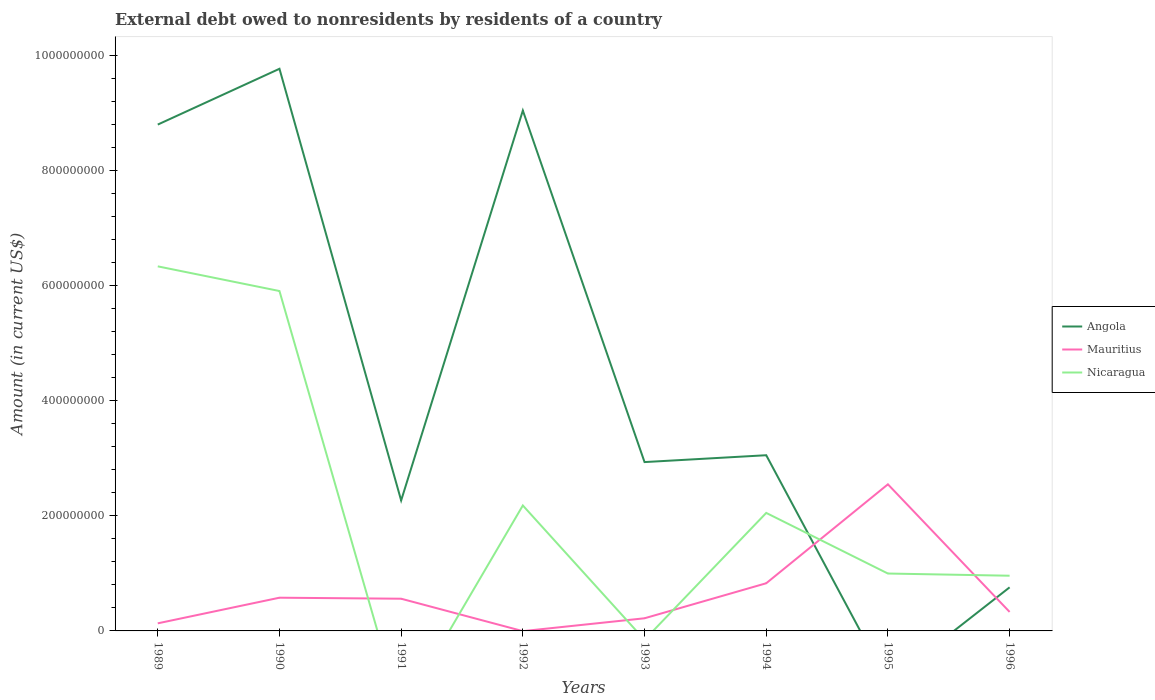Does the line corresponding to Angola intersect with the line corresponding to Nicaragua?
Provide a short and direct response. Yes. What is the total external debt owed by residents in Angola in the graph?
Your answer should be compact. -6.78e+08. What is the difference between the highest and the second highest external debt owed by residents in Angola?
Give a very brief answer. 9.77e+08. What is the difference between the highest and the lowest external debt owed by residents in Angola?
Provide a short and direct response. 3. How many lines are there?
Give a very brief answer. 3. How many years are there in the graph?
Your answer should be very brief. 8. What is the difference between two consecutive major ticks on the Y-axis?
Keep it short and to the point. 2.00e+08. Are the values on the major ticks of Y-axis written in scientific E-notation?
Your answer should be very brief. No. Does the graph contain any zero values?
Your answer should be compact. Yes. Does the graph contain grids?
Provide a succinct answer. No. Where does the legend appear in the graph?
Keep it short and to the point. Center right. What is the title of the graph?
Your answer should be very brief. External debt owed to nonresidents by residents of a country. What is the label or title of the X-axis?
Give a very brief answer. Years. What is the Amount (in current US$) in Angola in 1989?
Offer a terse response. 8.80e+08. What is the Amount (in current US$) in Mauritius in 1989?
Make the answer very short. 1.32e+07. What is the Amount (in current US$) in Nicaragua in 1989?
Provide a short and direct response. 6.34e+08. What is the Amount (in current US$) of Angola in 1990?
Offer a terse response. 9.77e+08. What is the Amount (in current US$) in Mauritius in 1990?
Offer a terse response. 5.77e+07. What is the Amount (in current US$) of Nicaragua in 1990?
Your answer should be very brief. 5.91e+08. What is the Amount (in current US$) in Angola in 1991?
Keep it short and to the point. 2.27e+08. What is the Amount (in current US$) in Mauritius in 1991?
Your answer should be very brief. 5.60e+07. What is the Amount (in current US$) in Nicaragua in 1991?
Your response must be concise. 0. What is the Amount (in current US$) of Angola in 1992?
Make the answer very short. 9.05e+08. What is the Amount (in current US$) of Mauritius in 1992?
Your answer should be very brief. 0. What is the Amount (in current US$) of Nicaragua in 1992?
Make the answer very short. 2.18e+08. What is the Amount (in current US$) of Angola in 1993?
Your response must be concise. 2.94e+08. What is the Amount (in current US$) in Mauritius in 1993?
Your answer should be compact. 2.20e+07. What is the Amount (in current US$) of Nicaragua in 1993?
Your answer should be very brief. 0. What is the Amount (in current US$) of Angola in 1994?
Provide a succinct answer. 3.05e+08. What is the Amount (in current US$) in Mauritius in 1994?
Keep it short and to the point. 8.28e+07. What is the Amount (in current US$) in Nicaragua in 1994?
Keep it short and to the point. 2.05e+08. What is the Amount (in current US$) in Angola in 1995?
Your answer should be compact. 0. What is the Amount (in current US$) in Mauritius in 1995?
Your answer should be compact. 2.55e+08. What is the Amount (in current US$) of Nicaragua in 1995?
Offer a very short reply. 9.98e+07. What is the Amount (in current US$) of Angola in 1996?
Keep it short and to the point. 7.58e+07. What is the Amount (in current US$) of Mauritius in 1996?
Provide a succinct answer. 3.30e+07. What is the Amount (in current US$) of Nicaragua in 1996?
Give a very brief answer. 9.60e+07. Across all years, what is the maximum Amount (in current US$) in Angola?
Your response must be concise. 9.77e+08. Across all years, what is the maximum Amount (in current US$) in Mauritius?
Provide a succinct answer. 2.55e+08. Across all years, what is the maximum Amount (in current US$) in Nicaragua?
Provide a short and direct response. 6.34e+08. Across all years, what is the minimum Amount (in current US$) in Angola?
Provide a short and direct response. 0. Across all years, what is the minimum Amount (in current US$) of Mauritius?
Keep it short and to the point. 0. What is the total Amount (in current US$) in Angola in the graph?
Ensure brevity in your answer.  3.66e+09. What is the total Amount (in current US$) of Mauritius in the graph?
Your answer should be very brief. 5.20e+08. What is the total Amount (in current US$) in Nicaragua in the graph?
Ensure brevity in your answer.  1.84e+09. What is the difference between the Amount (in current US$) in Angola in 1989 and that in 1990?
Ensure brevity in your answer.  -9.70e+07. What is the difference between the Amount (in current US$) in Mauritius in 1989 and that in 1990?
Your response must be concise. -4.45e+07. What is the difference between the Amount (in current US$) of Nicaragua in 1989 and that in 1990?
Your response must be concise. 4.29e+07. What is the difference between the Amount (in current US$) of Angola in 1989 and that in 1991?
Your answer should be compact. 6.53e+08. What is the difference between the Amount (in current US$) of Mauritius in 1989 and that in 1991?
Your answer should be very brief. -4.28e+07. What is the difference between the Amount (in current US$) of Angola in 1989 and that in 1992?
Make the answer very short. -2.44e+07. What is the difference between the Amount (in current US$) in Nicaragua in 1989 and that in 1992?
Offer a terse response. 4.16e+08. What is the difference between the Amount (in current US$) in Angola in 1989 and that in 1993?
Your answer should be compact. 5.87e+08. What is the difference between the Amount (in current US$) in Mauritius in 1989 and that in 1993?
Offer a very short reply. -8.78e+06. What is the difference between the Amount (in current US$) in Angola in 1989 and that in 1994?
Your answer should be compact. 5.75e+08. What is the difference between the Amount (in current US$) of Mauritius in 1989 and that in 1994?
Your response must be concise. -6.97e+07. What is the difference between the Amount (in current US$) of Nicaragua in 1989 and that in 1994?
Give a very brief answer. 4.29e+08. What is the difference between the Amount (in current US$) of Mauritius in 1989 and that in 1995?
Offer a terse response. -2.42e+08. What is the difference between the Amount (in current US$) in Nicaragua in 1989 and that in 1995?
Keep it short and to the point. 5.34e+08. What is the difference between the Amount (in current US$) of Angola in 1989 and that in 1996?
Offer a very short reply. 8.04e+08. What is the difference between the Amount (in current US$) in Mauritius in 1989 and that in 1996?
Make the answer very short. -1.98e+07. What is the difference between the Amount (in current US$) in Nicaragua in 1989 and that in 1996?
Your response must be concise. 5.38e+08. What is the difference between the Amount (in current US$) of Angola in 1990 and that in 1991?
Offer a very short reply. 7.50e+08. What is the difference between the Amount (in current US$) of Mauritius in 1990 and that in 1991?
Your answer should be very brief. 1.76e+06. What is the difference between the Amount (in current US$) in Angola in 1990 and that in 1992?
Offer a terse response. 7.26e+07. What is the difference between the Amount (in current US$) in Nicaragua in 1990 and that in 1992?
Make the answer very short. 3.73e+08. What is the difference between the Amount (in current US$) in Angola in 1990 and that in 1993?
Make the answer very short. 6.84e+08. What is the difference between the Amount (in current US$) in Mauritius in 1990 and that in 1993?
Make the answer very short. 3.58e+07. What is the difference between the Amount (in current US$) of Angola in 1990 and that in 1994?
Your answer should be very brief. 6.72e+08. What is the difference between the Amount (in current US$) of Mauritius in 1990 and that in 1994?
Ensure brevity in your answer.  -2.51e+07. What is the difference between the Amount (in current US$) in Nicaragua in 1990 and that in 1994?
Provide a short and direct response. 3.86e+08. What is the difference between the Amount (in current US$) in Mauritius in 1990 and that in 1995?
Ensure brevity in your answer.  -1.97e+08. What is the difference between the Amount (in current US$) of Nicaragua in 1990 and that in 1995?
Provide a short and direct response. 4.91e+08. What is the difference between the Amount (in current US$) of Angola in 1990 and that in 1996?
Make the answer very short. 9.01e+08. What is the difference between the Amount (in current US$) of Mauritius in 1990 and that in 1996?
Provide a succinct answer. 2.47e+07. What is the difference between the Amount (in current US$) of Nicaragua in 1990 and that in 1996?
Provide a short and direct response. 4.95e+08. What is the difference between the Amount (in current US$) of Angola in 1991 and that in 1992?
Your answer should be very brief. -6.78e+08. What is the difference between the Amount (in current US$) in Angola in 1991 and that in 1993?
Offer a terse response. -6.67e+07. What is the difference between the Amount (in current US$) in Mauritius in 1991 and that in 1993?
Offer a very short reply. 3.40e+07. What is the difference between the Amount (in current US$) in Angola in 1991 and that in 1994?
Give a very brief answer. -7.86e+07. What is the difference between the Amount (in current US$) of Mauritius in 1991 and that in 1994?
Ensure brevity in your answer.  -2.69e+07. What is the difference between the Amount (in current US$) in Mauritius in 1991 and that in 1995?
Provide a succinct answer. -1.99e+08. What is the difference between the Amount (in current US$) in Angola in 1991 and that in 1996?
Give a very brief answer. 1.51e+08. What is the difference between the Amount (in current US$) in Mauritius in 1991 and that in 1996?
Give a very brief answer. 2.30e+07. What is the difference between the Amount (in current US$) in Angola in 1992 and that in 1993?
Provide a short and direct response. 6.11e+08. What is the difference between the Amount (in current US$) of Angola in 1992 and that in 1994?
Your response must be concise. 5.99e+08. What is the difference between the Amount (in current US$) in Nicaragua in 1992 and that in 1994?
Your answer should be compact. 1.30e+07. What is the difference between the Amount (in current US$) of Nicaragua in 1992 and that in 1995?
Your answer should be compact. 1.18e+08. What is the difference between the Amount (in current US$) of Angola in 1992 and that in 1996?
Make the answer very short. 8.29e+08. What is the difference between the Amount (in current US$) in Nicaragua in 1992 and that in 1996?
Ensure brevity in your answer.  1.22e+08. What is the difference between the Amount (in current US$) in Angola in 1993 and that in 1994?
Ensure brevity in your answer.  -1.19e+07. What is the difference between the Amount (in current US$) of Mauritius in 1993 and that in 1994?
Provide a succinct answer. -6.09e+07. What is the difference between the Amount (in current US$) in Mauritius in 1993 and that in 1995?
Offer a terse response. -2.33e+08. What is the difference between the Amount (in current US$) of Angola in 1993 and that in 1996?
Give a very brief answer. 2.18e+08. What is the difference between the Amount (in current US$) of Mauritius in 1993 and that in 1996?
Make the answer very short. -1.10e+07. What is the difference between the Amount (in current US$) of Mauritius in 1994 and that in 1995?
Your answer should be compact. -1.72e+08. What is the difference between the Amount (in current US$) of Nicaragua in 1994 and that in 1995?
Offer a very short reply. 1.05e+08. What is the difference between the Amount (in current US$) in Angola in 1994 and that in 1996?
Ensure brevity in your answer.  2.30e+08. What is the difference between the Amount (in current US$) of Mauritius in 1994 and that in 1996?
Your response must be concise. 4.98e+07. What is the difference between the Amount (in current US$) in Nicaragua in 1994 and that in 1996?
Give a very brief answer. 1.09e+08. What is the difference between the Amount (in current US$) of Mauritius in 1995 and that in 1996?
Your response must be concise. 2.22e+08. What is the difference between the Amount (in current US$) of Nicaragua in 1995 and that in 1996?
Offer a very short reply. 3.80e+06. What is the difference between the Amount (in current US$) of Angola in 1989 and the Amount (in current US$) of Mauritius in 1990?
Your answer should be compact. 8.22e+08. What is the difference between the Amount (in current US$) in Angola in 1989 and the Amount (in current US$) in Nicaragua in 1990?
Ensure brevity in your answer.  2.89e+08. What is the difference between the Amount (in current US$) of Mauritius in 1989 and the Amount (in current US$) of Nicaragua in 1990?
Make the answer very short. -5.78e+08. What is the difference between the Amount (in current US$) of Angola in 1989 and the Amount (in current US$) of Mauritius in 1991?
Your answer should be very brief. 8.24e+08. What is the difference between the Amount (in current US$) of Angola in 1989 and the Amount (in current US$) of Nicaragua in 1992?
Your response must be concise. 6.62e+08. What is the difference between the Amount (in current US$) of Mauritius in 1989 and the Amount (in current US$) of Nicaragua in 1992?
Offer a very short reply. -2.05e+08. What is the difference between the Amount (in current US$) of Angola in 1989 and the Amount (in current US$) of Mauritius in 1993?
Offer a very short reply. 8.58e+08. What is the difference between the Amount (in current US$) of Angola in 1989 and the Amount (in current US$) of Mauritius in 1994?
Offer a very short reply. 7.97e+08. What is the difference between the Amount (in current US$) in Angola in 1989 and the Amount (in current US$) in Nicaragua in 1994?
Offer a terse response. 6.75e+08. What is the difference between the Amount (in current US$) in Mauritius in 1989 and the Amount (in current US$) in Nicaragua in 1994?
Your response must be concise. -1.92e+08. What is the difference between the Amount (in current US$) in Angola in 1989 and the Amount (in current US$) in Mauritius in 1995?
Your answer should be compact. 6.25e+08. What is the difference between the Amount (in current US$) of Angola in 1989 and the Amount (in current US$) of Nicaragua in 1995?
Your answer should be very brief. 7.80e+08. What is the difference between the Amount (in current US$) of Mauritius in 1989 and the Amount (in current US$) of Nicaragua in 1995?
Offer a very short reply. -8.66e+07. What is the difference between the Amount (in current US$) in Angola in 1989 and the Amount (in current US$) in Mauritius in 1996?
Make the answer very short. 8.47e+08. What is the difference between the Amount (in current US$) of Angola in 1989 and the Amount (in current US$) of Nicaragua in 1996?
Keep it short and to the point. 7.84e+08. What is the difference between the Amount (in current US$) in Mauritius in 1989 and the Amount (in current US$) in Nicaragua in 1996?
Your answer should be compact. -8.28e+07. What is the difference between the Amount (in current US$) in Angola in 1990 and the Amount (in current US$) in Mauritius in 1991?
Give a very brief answer. 9.21e+08. What is the difference between the Amount (in current US$) of Angola in 1990 and the Amount (in current US$) of Nicaragua in 1992?
Provide a short and direct response. 7.59e+08. What is the difference between the Amount (in current US$) of Mauritius in 1990 and the Amount (in current US$) of Nicaragua in 1992?
Offer a terse response. -1.60e+08. What is the difference between the Amount (in current US$) of Angola in 1990 and the Amount (in current US$) of Mauritius in 1993?
Offer a terse response. 9.55e+08. What is the difference between the Amount (in current US$) in Angola in 1990 and the Amount (in current US$) in Mauritius in 1994?
Provide a succinct answer. 8.94e+08. What is the difference between the Amount (in current US$) of Angola in 1990 and the Amount (in current US$) of Nicaragua in 1994?
Offer a terse response. 7.72e+08. What is the difference between the Amount (in current US$) of Mauritius in 1990 and the Amount (in current US$) of Nicaragua in 1994?
Your response must be concise. -1.47e+08. What is the difference between the Amount (in current US$) in Angola in 1990 and the Amount (in current US$) in Mauritius in 1995?
Make the answer very short. 7.22e+08. What is the difference between the Amount (in current US$) in Angola in 1990 and the Amount (in current US$) in Nicaragua in 1995?
Offer a very short reply. 8.77e+08. What is the difference between the Amount (in current US$) of Mauritius in 1990 and the Amount (in current US$) of Nicaragua in 1995?
Provide a succinct answer. -4.20e+07. What is the difference between the Amount (in current US$) in Angola in 1990 and the Amount (in current US$) in Mauritius in 1996?
Your answer should be very brief. 9.44e+08. What is the difference between the Amount (in current US$) of Angola in 1990 and the Amount (in current US$) of Nicaragua in 1996?
Provide a short and direct response. 8.81e+08. What is the difference between the Amount (in current US$) of Mauritius in 1990 and the Amount (in current US$) of Nicaragua in 1996?
Your answer should be compact. -3.82e+07. What is the difference between the Amount (in current US$) of Angola in 1991 and the Amount (in current US$) of Nicaragua in 1992?
Give a very brief answer. 8.74e+06. What is the difference between the Amount (in current US$) in Mauritius in 1991 and the Amount (in current US$) in Nicaragua in 1992?
Make the answer very short. -1.62e+08. What is the difference between the Amount (in current US$) of Angola in 1991 and the Amount (in current US$) of Mauritius in 1993?
Provide a succinct answer. 2.05e+08. What is the difference between the Amount (in current US$) in Angola in 1991 and the Amount (in current US$) in Mauritius in 1994?
Offer a terse response. 1.44e+08. What is the difference between the Amount (in current US$) in Angola in 1991 and the Amount (in current US$) in Nicaragua in 1994?
Make the answer very short. 2.17e+07. What is the difference between the Amount (in current US$) of Mauritius in 1991 and the Amount (in current US$) of Nicaragua in 1994?
Provide a short and direct response. -1.49e+08. What is the difference between the Amount (in current US$) of Angola in 1991 and the Amount (in current US$) of Mauritius in 1995?
Provide a succinct answer. -2.80e+07. What is the difference between the Amount (in current US$) in Angola in 1991 and the Amount (in current US$) in Nicaragua in 1995?
Offer a very short reply. 1.27e+08. What is the difference between the Amount (in current US$) in Mauritius in 1991 and the Amount (in current US$) in Nicaragua in 1995?
Your answer should be compact. -4.38e+07. What is the difference between the Amount (in current US$) in Angola in 1991 and the Amount (in current US$) in Mauritius in 1996?
Make the answer very short. 1.94e+08. What is the difference between the Amount (in current US$) of Angola in 1991 and the Amount (in current US$) of Nicaragua in 1996?
Keep it short and to the point. 1.31e+08. What is the difference between the Amount (in current US$) in Mauritius in 1991 and the Amount (in current US$) in Nicaragua in 1996?
Your answer should be very brief. -4.00e+07. What is the difference between the Amount (in current US$) in Angola in 1992 and the Amount (in current US$) in Mauritius in 1993?
Your answer should be compact. 8.83e+08. What is the difference between the Amount (in current US$) in Angola in 1992 and the Amount (in current US$) in Mauritius in 1994?
Provide a short and direct response. 8.22e+08. What is the difference between the Amount (in current US$) of Angola in 1992 and the Amount (in current US$) of Nicaragua in 1994?
Your response must be concise. 6.99e+08. What is the difference between the Amount (in current US$) of Angola in 1992 and the Amount (in current US$) of Mauritius in 1995?
Your response must be concise. 6.50e+08. What is the difference between the Amount (in current US$) in Angola in 1992 and the Amount (in current US$) in Nicaragua in 1995?
Ensure brevity in your answer.  8.05e+08. What is the difference between the Amount (in current US$) of Angola in 1992 and the Amount (in current US$) of Mauritius in 1996?
Offer a very short reply. 8.72e+08. What is the difference between the Amount (in current US$) in Angola in 1992 and the Amount (in current US$) in Nicaragua in 1996?
Provide a short and direct response. 8.09e+08. What is the difference between the Amount (in current US$) in Angola in 1993 and the Amount (in current US$) in Mauritius in 1994?
Provide a short and direct response. 2.11e+08. What is the difference between the Amount (in current US$) of Angola in 1993 and the Amount (in current US$) of Nicaragua in 1994?
Offer a terse response. 8.84e+07. What is the difference between the Amount (in current US$) of Mauritius in 1993 and the Amount (in current US$) of Nicaragua in 1994?
Offer a very short reply. -1.83e+08. What is the difference between the Amount (in current US$) of Angola in 1993 and the Amount (in current US$) of Mauritius in 1995?
Offer a very short reply. 3.87e+07. What is the difference between the Amount (in current US$) of Angola in 1993 and the Amount (in current US$) of Nicaragua in 1995?
Keep it short and to the point. 1.94e+08. What is the difference between the Amount (in current US$) of Mauritius in 1993 and the Amount (in current US$) of Nicaragua in 1995?
Provide a succinct answer. -7.78e+07. What is the difference between the Amount (in current US$) of Angola in 1993 and the Amount (in current US$) of Mauritius in 1996?
Your answer should be compact. 2.60e+08. What is the difference between the Amount (in current US$) of Angola in 1993 and the Amount (in current US$) of Nicaragua in 1996?
Provide a succinct answer. 1.98e+08. What is the difference between the Amount (in current US$) in Mauritius in 1993 and the Amount (in current US$) in Nicaragua in 1996?
Your response must be concise. -7.40e+07. What is the difference between the Amount (in current US$) of Angola in 1994 and the Amount (in current US$) of Mauritius in 1995?
Keep it short and to the point. 5.06e+07. What is the difference between the Amount (in current US$) in Angola in 1994 and the Amount (in current US$) in Nicaragua in 1995?
Make the answer very short. 2.06e+08. What is the difference between the Amount (in current US$) of Mauritius in 1994 and the Amount (in current US$) of Nicaragua in 1995?
Offer a very short reply. -1.69e+07. What is the difference between the Amount (in current US$) of Angola in 1994 and the Amount (in current US$) of Mauritius in 1996?
Your response must be concise. 2.72e+08. What is the difference between the Amount (in current US$) of Angola in 1994 and the Amount (in current US$) of Nicaragua in 1996?
Offer a very short reply. 2.09e+08. What is the difference between the Amount (in current US$) of Mauritius in 1994 and the Amount (in current US$) of Nicaragua in 1996?
Your response must be concise. -1.31e+07. What is the difference between the Amount (in current US$) in Mauritius in 1995 and the Amount (in current US$) in Nicaragua in 1996?
Keep it short and to the point. 1.59e+08. What is the average Amount (in current US$) of Angola per year?
Ensure brevity in your answer.  4.58e+08. What is the average Amount (in current US$) in Mauritius per year?
Your response must be concise. 6.49e+07. What is the average Amount (in current US$) in Nicaragua per year?
Give a very brief answer. 2.30e+08. In the year 1989, what is the difference between the Amount (in current US$) of Angola and Amount (in current US$) of Mauritius?
Provide a short and direct response. 8.67e+08. In the year 1989, what is the difference between the Amount (in current US$) of Angola and Amount (in current US$) of Nicaragua?
Offer a terse response. 2.46e+08. In the year 1989, what is the difference between the Amount (in current US$) of Mauritius and Amount (in current US$) of Nicaragua?
Your answer should be compact. -6.21e+08. In the year 1990, what is the difference between the Amount (in current US$) in Angola and Amount (in current US$) in Mauritius?
Your answer should be compact. 9.19e+08. In the year 1990, what is the difference between the Amount (in current US$) in Angola and Amount (in current US$) in Nicaragua?
Offer a terse response. 3.86e+08. In the year 1990, what is the difference between the Amount (in current US$) of Mauritius and Amount (in current US$) of Nicaragua?
Your answer should be very brief. -5.33e+08. In the year 1991, what is the difference between the Amount (in current US$) of Angola and Amount (in current US$) of Mauritius?
Provide a short and direct response. 1.71e+08. In the year 1992, what is the difference between the Amount (in current US$) of Angola and Amount (in current US$) of Nicaragua?
Ensure brevity in your answer.  6.86e+08. In the year 1993, what is the difference between the Amount (in current US$) of Angola and Amount (in current US$) of Mauritius?
Give a very brief answer. 2.72e+08. In the year 1994, what is the difference between the Amount (in current US$) of Angola and Amount (in current US$) of Mauritius?
Your response must be concise. 2.23e+08. In the year 1994, what is the difference between the Amount (in current US$) in Angola and Amount (in current US$) in Nicaragua?
Your response must be concise. 1.00e+08. In the year 1994, what is the difference between the Amount (in current US$) in Mauritius and Amount (in current US$) in Nicaragua?
Your response must be concise. -1.22e+08. In the year 1995, what is the difference between the Amount (in current US$) of Mauritius and Amount (in current US$) of Nicaragua?
Your answer should be compact. 1.55e+08. In the year 1996, what is the difference between the Amount (in current US$) in Angola and Amount (in current US$) in Mauritius?
Keep it short and to the point. 4.27e+07. In the year 1996, what is the difference between the Amount (in current US$) of Angola and Amount (in current US$) of Nicaragua?
Keep it short and to the point. -2.02e+07. In the year 1996, what is the difference between the Amount (in current US$) in Mauritius and Amount (in current US$) in Nicaragua?
Keep it short and to the point. -6.29e+07. What is the ratio of the Amount (in current US$) of Angola in 1989 to that in 1990?
Offer a terse response. 0.9. What is the ratio of the Amount (in current US$) of Mauritius in 1989 to that in 1990?
Your response must be concise. 0.23. What is the ratio of the Amount (in current US$) in Nicaragua in 1989 to that in 1990?
Provide a short and direct response. 1.07. What is the ratio of the Amount (in current US$) in Angola in 1989 to that in 1991?
Your response must be concise. 3.88. What is the ratio of the Amount (in current US$) of Mauritius in 1989 to that in 1991?
Give a very brief answer. 0.24. What is the ratio of the Amount (in current US$) of Angola in 1989 to that in 1992?
Make the answer very short. 0.97. What is the ratio of the Amount (in current US$) of Nicaragua in 1989 to that in 1992?
Give a very brief answer. 2.91. What is the ratio of the Amount (in current US$) in Angola in 1989 to that in 1993?
Make the answer very short. 3. What is the ratio of the Amount (in current US$) in Mauritius in 1989 to that in 1993?
Provide a succinct answer. 0.6. What is the ratio of the Amount (in current US$) of Angola in 1989 to that in 1994?
Make the answer very short. 2.88. What is the ratio of the Amount (in current US$) in Mauritius in 1989 to that in 1994?
Provide a succinct answer. 0.16. What is the ratio of the Amount (in current US$) of Nicaragua in 1989 to that in 1994?
Ensure brevity in your answer.  3.09. What is the ratio of the Amount (in current US$) in Mauritius in 1989 to that in 1995?
Provide a short and direct response. 0.05. What is the ratio of the Amount (in current US$) of Nicaragua in 1989 to that in 1995?
Your response must be concise. 6.35. What is the ratio of the Amount (in current US$) in Angola in 1989 to that in 1996?
Provide a short and direct response. 11.62. What is the ratio of the Amount (in current US$) in Mauritius in 1989 to that in 1996?
Keep it short and to the point. 0.4. What is the ratio of the Amount (in current US$) in Nicaragua in 1989 to that in 1996?
Provide a short and direct response. 6.6. What is the ratio of the Amount (in current US$) in Angola in 1990 to that in 1991?
Keep it short and to the point. 4.31. What is the ratio of the Amount (in current US$) in Mauritius in 1990 to that in 1991?
Keep it short and to the point. 1.03. What is the ratio of the Amount (in current US$) in Angola in 1990 to that in 1992?
Ensure brevity in your answer.  1.08. What is the ratio of the Amount (in current US$) in Nicaragua in 1990 to that in 1992?
Your answer should be compact. 2.71. What is the ratio of the Amount (in current US$) of Angola in 1990 to that in 1993?
Make the answer very short. 3.33. What is the ratio of the Amount (in current US$) in Mauritius in 1990 to that in 1993?
Ensure brevity in your answer.  2.63. What is the ratio of the Amount (in current US$) in Angola in 1990 to that in 1994?
Provide a succinct answer. 3.2. What is the ratio of the Amount (in current US$) in Mauritius in 1990 to that in 1994?
Make the answer very short. 0.7. What is the ratio of the Amount (in current US$) of Nicaragua in 1990 to that in 1994?
Your response must be concise. 2.88. What is the ratio of the Amount (in current US$) of Mauritius in 1990 to that in 1995?
Offer a terse response. 0.23. What is the ratio of the Amount (in current US$) in Nicaragua in 1990 to that in 1995?
Your answer should be compact. 5.92. What is the ratio of the Amount (in current US$) of Angola in 1990 to that in 1996?
Your response must be concise. 12.9. What is the ratio of the Amount (in current US$) in Mauritius in 1990 to that in 1996?
Ensure brevity in your answer.  1.75. What is the ratio of the Amount (in current US$) in Nicaragua in 1990 to that in 1996?
Make the answer very short. 6.16. What is the ratio of the Amount (in current US$) in Angola in 1991 to that in 1992?
Make the answer very short. 0.25. What is the ratio of the Amount (in current US$) of Angola in 1991 to that in 1993?
Provide a short and direct response. 0.77. What is the ratio of the Amount (in current US$) of Mauritius in 1991 to that in 1993?
Your answer should be compact. 2.55. What is the ratio of the Amount (in current US$) in Angola in 1991 to that in 1994?
Your response must be concise. 0.74. What is the ratio of the Amount (in current US$) in Mauritius in 1991 to that in 1994?
Make the answer very short. 0.68. What is the ratio of the Amount (in current US$) of Mauritius in 1991 to that in 1995?
Your response must be concise. 0.22. What is the ratio of the Amount (in current US$) in Angola in 1991 to that in 1996?
Offer a terse response. 2.99. What is the ratio of the Amount (in current US$) of Mauritius in 1991 to that in 1996?
Your answer should be compact. 1.7. What is the ratio of the Amount (in current US$) in Angola in 1992 to that in 1993?
Make the answer very short. 3.08. What is the ratio of the Amount (in current US$) of Angola in 1992 to that in 1994?
Provide a succinct answer. 2.96. What is the ratio of the Amount (in current US$) of Nicaragua in 1992 to that in 1994?
Offer a very short reply. 1.06. What is the ratio of the Amount (in current US$) in Nicaragua in 1992 to that in 1995?
Give a very brief answer. 2.19. What is the ratio of the Amount (in current US$) of Angola in 1992 to that in 1996?
Ensure brevity in your answer.  11.94. What is the ratio of the Amount (in current US$) of Nicaragua in 1992 to that in 1996?
Ensure brevity in your answer.  2.27. What is the ratio of the Amount (in current US$) of Mauritius in 1993 to that in 1994?
Your answer should be very brief. 0.27. What is the ratio of the Amount (in current US$) in Mauritius in 1993 to that in 1995?
Provide a succinct answer. 0.09. What is the ratio of the Amount (in current US$) of Angola in 1993 to that in 1996?
Your answer should be compact. 3.87. What is the ratio of the Amount (in current US$) of Mauritius in 1993 to that in 1996?
Provide a succinct answer. 0.67. What is the ratio of the Amount (in current US$) of Mauritius in 1994 to that in 1995?
Provide a short and direct response. 0.33. What is the ratio of the Amount (in current US$) of Nicaragua in 1994 to that in 1995?
Keep it short and to the point. 2.06. What is the ratio of the Amount (in current US$) of Angola in 1994 to that in 1996?
Provide a short and direct response. 4.03. What is the ratio of the Amount (in current US$) of Mauritius in 1994 to that in 1996?
Provide a short and direct response. 2.51. What is the ratio of the Amount (in current US$) of Nicaragua in 1994 to that in 1996?
Your answer should be very brief. 2.14. What is the ratio of the Amount (in current US$) in Mauritius in 1995 to that in 1996?
Make the answer very short. 7.72. What is the ratio of the Amount (in current US$) in Nicaragua in 1995 to that in 1996?
Your response must be concise. 1.04. What is the difference between the highest and the second highest Amount (in current US$) in Angola?
Provide a short and direct response. 7.26e+07. What is the difference between the highest and the second highest Amount (in current US$) in Mauritius?
Offer a terse response. 1.72e+08. What is the difference between the highest and the second highest Amount (in current US$) of Nicaragua?
Make the answer very short. 4.29e+07. What is the difference between the highest and the lowest Amount (in current US$) of Angola?
Provide a short and direct response. 9.77e+08. What is the difference between the highest and the lowest Amount (in current US$) in Mauritius?
Offer a terse response. 2.55e+08. What is the difference between the highest and the lowest Amount (in current US$) in Nicaragua?
Keep it short and to the point. 6.34e+08. 